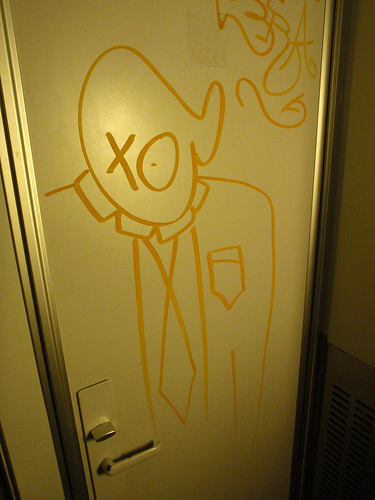<image>
Is the person on the door? Yes. Looking at the image, I can see the person is positioned on top of the door, with the door providing support. Is the circle above the diamond? Yes. The circle is positioned above the diamond in the vertical space, higher up in the scene. 